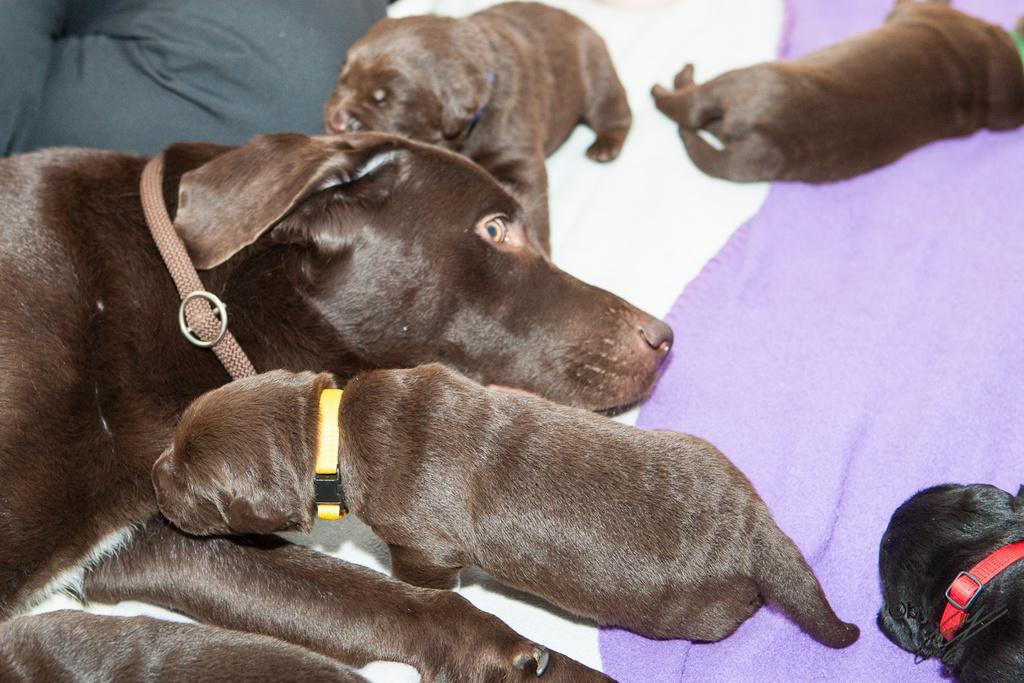What type of animal is in the picture? There is a dog in the picture. What color is the dog? The dog is black in color. Are there any other animals in the picture? Yes, there are puppies in the picture. What color are the puppies? The puppies are black in color. What are the puppies doing in the picture? The puppies are resting on a surface. Can you tell me where the seashore is located in the image? There is no seashore present in the image; it features a dog and puppies resting on a surface. What type of joke is the dog telling in the image? There is no joke being told in the image; it simply shows a dog and puppies resting on a surface. 